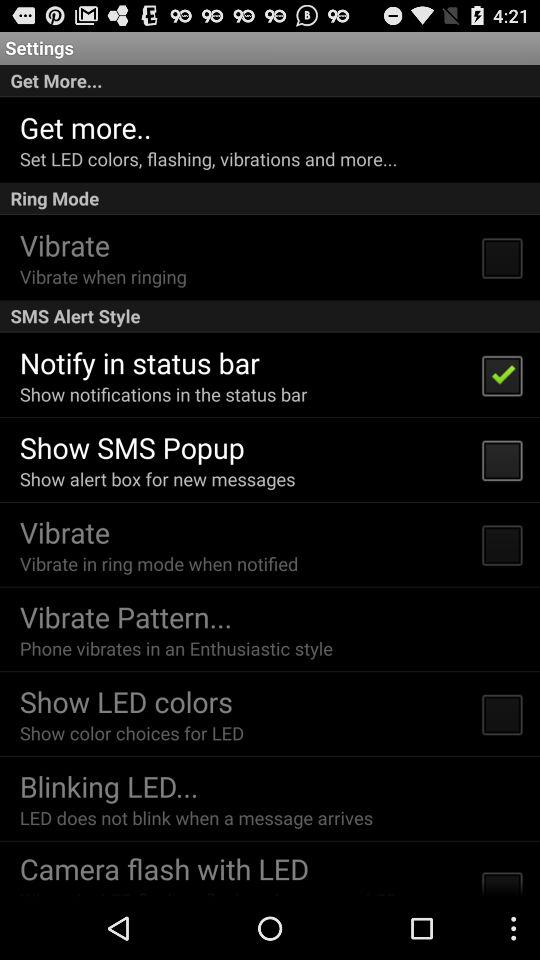What is the status of "Notify in status bar"? The status of "Notify in status bar" is "on". 